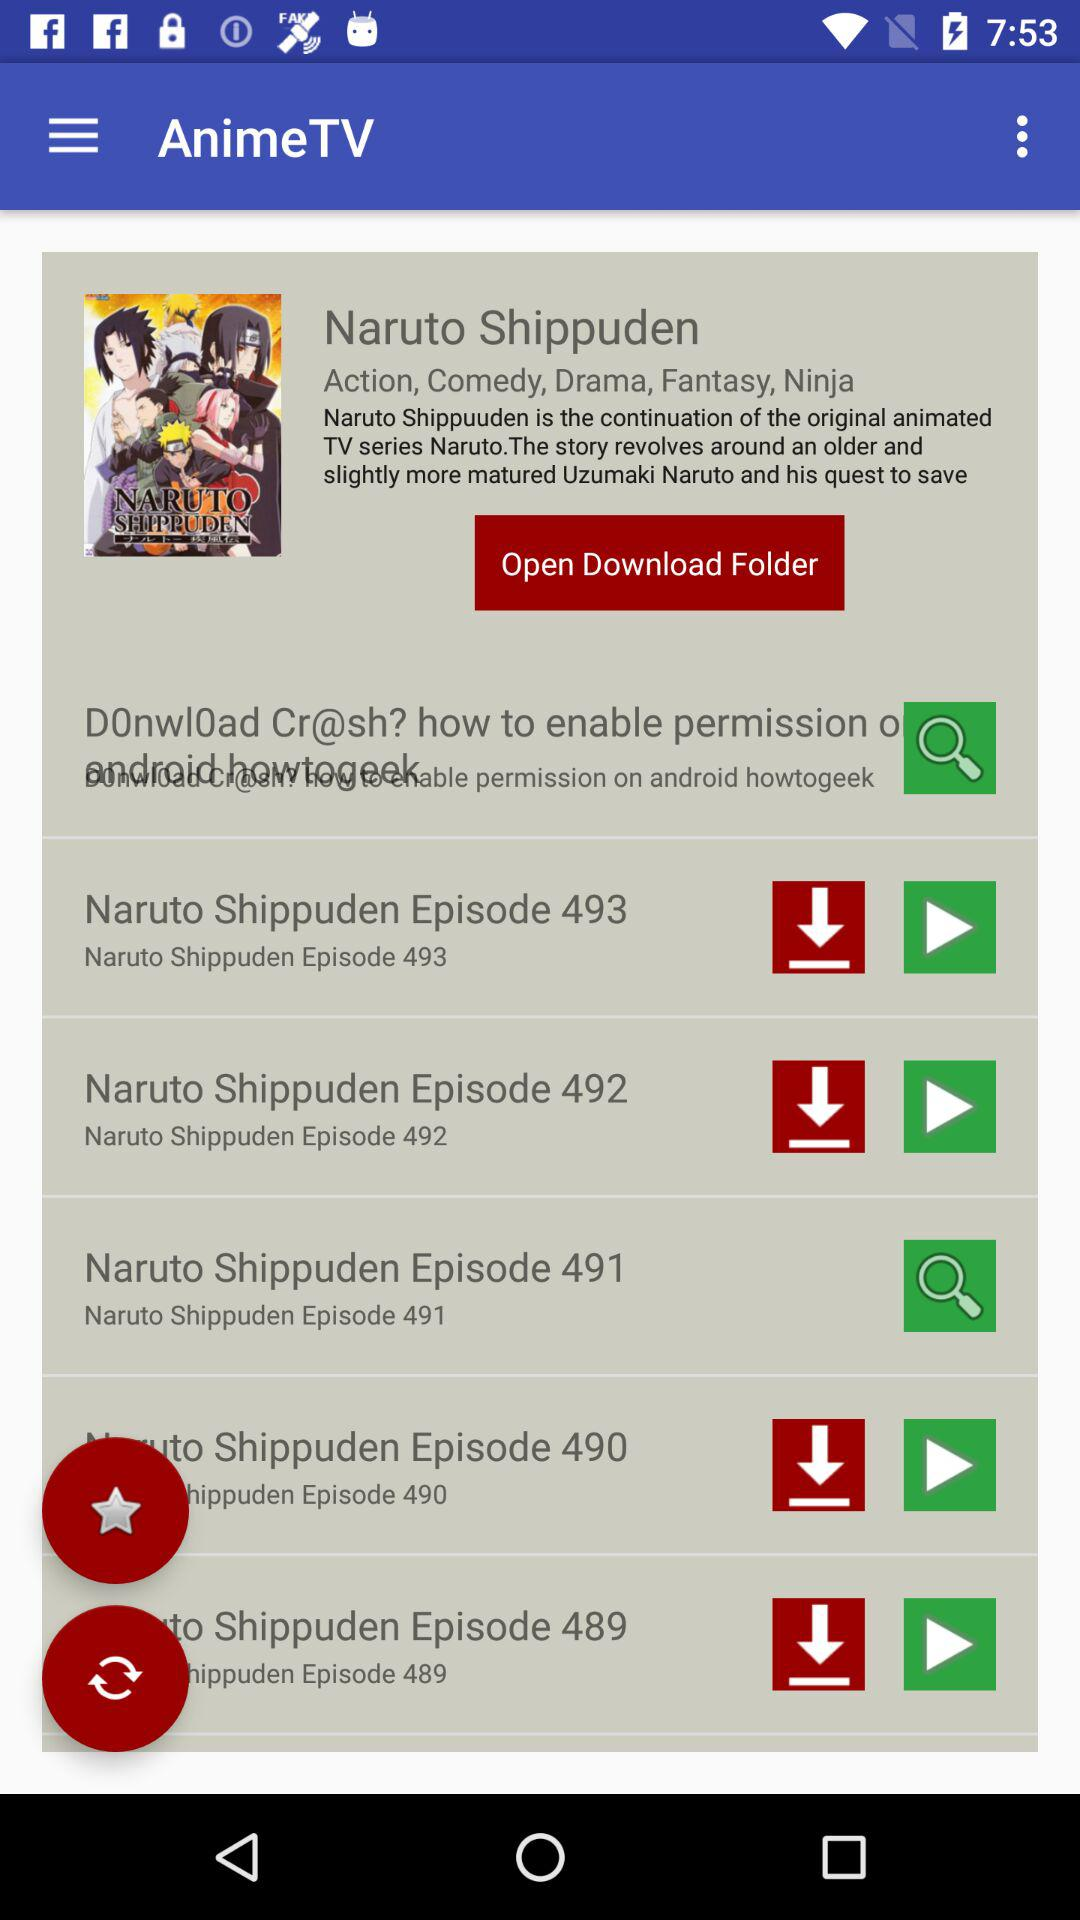What are the genres? The genres are action, comedy, drama, fantasy and ninja. 